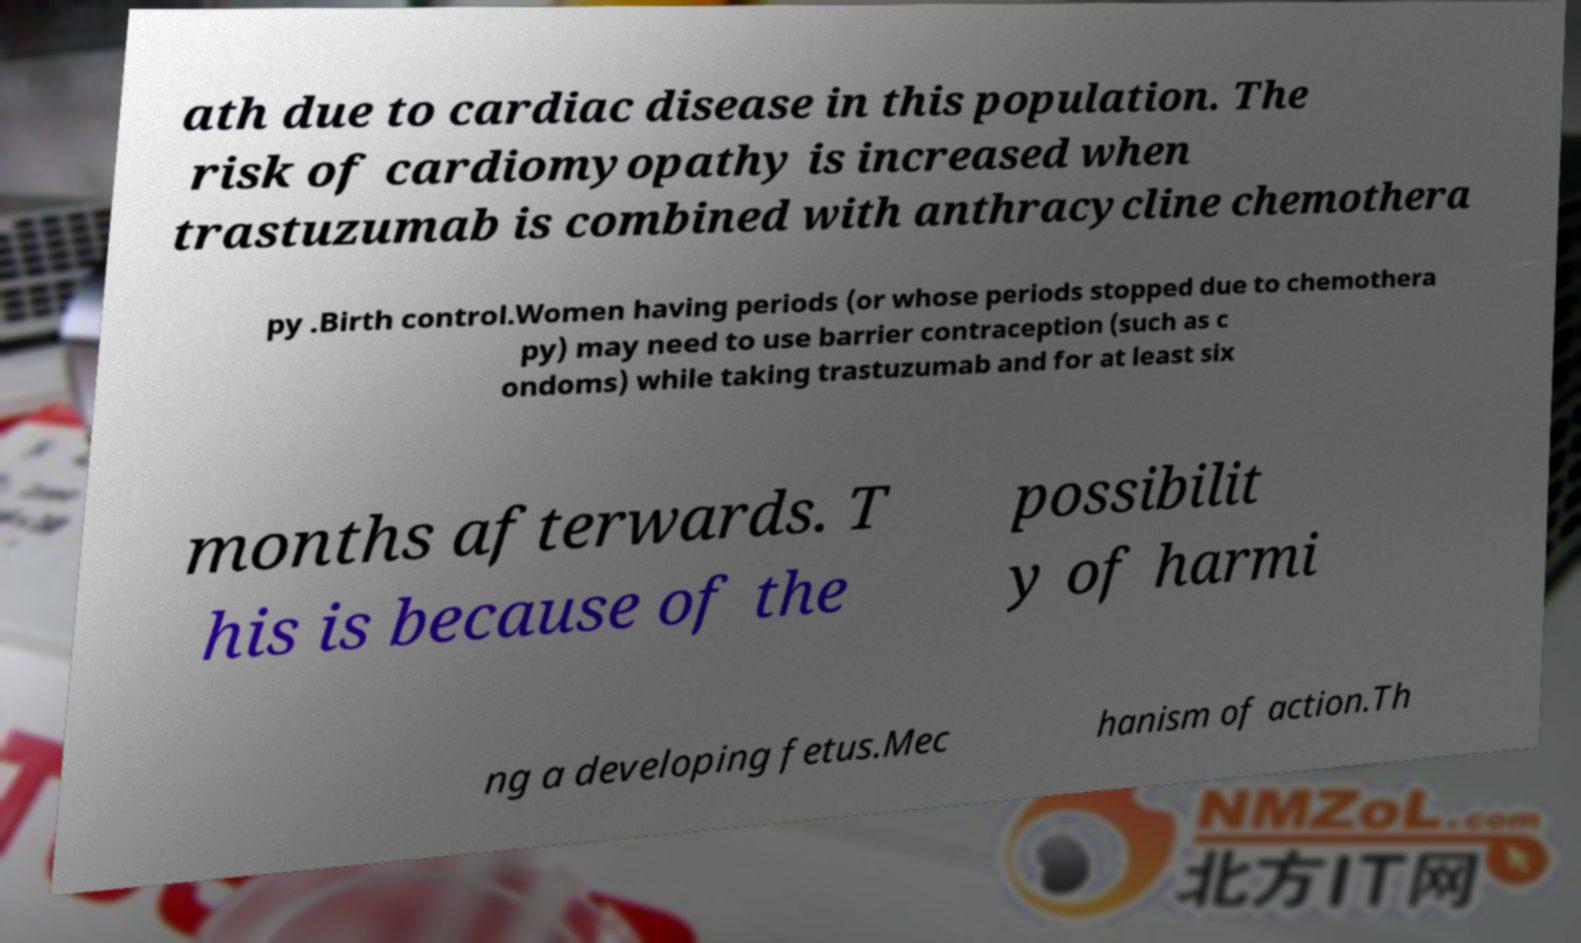Please read and relay the text visible in this image. What does it say? ath due to cardiac disease in this population. The risk of cardiomyopathy is increased when trastuzumab is combined with anthracycline chemothera py .Birth control.Women having periods (or whose periods stopped due to chemothera py) may need to use barrier contraception (such as c ondoms) while taking trastuzumab and for at least six months afterwards. T his is because of the possibilit y of harmi ng a developing fetus.Mec hanism of action.Th 